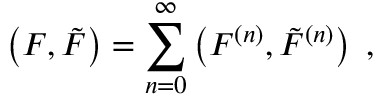Convert formula to latex. <formula><loc_0><loc_0><loc_500><loc_500>\left ( F , { \tilde { F } } \right ) = \sum _ { n = 0 } ^ { \infty } \left ( F ^ { ( n ) } , { \tilde { F } } ^ { ( n ) } \right ) \, ,</formula> 